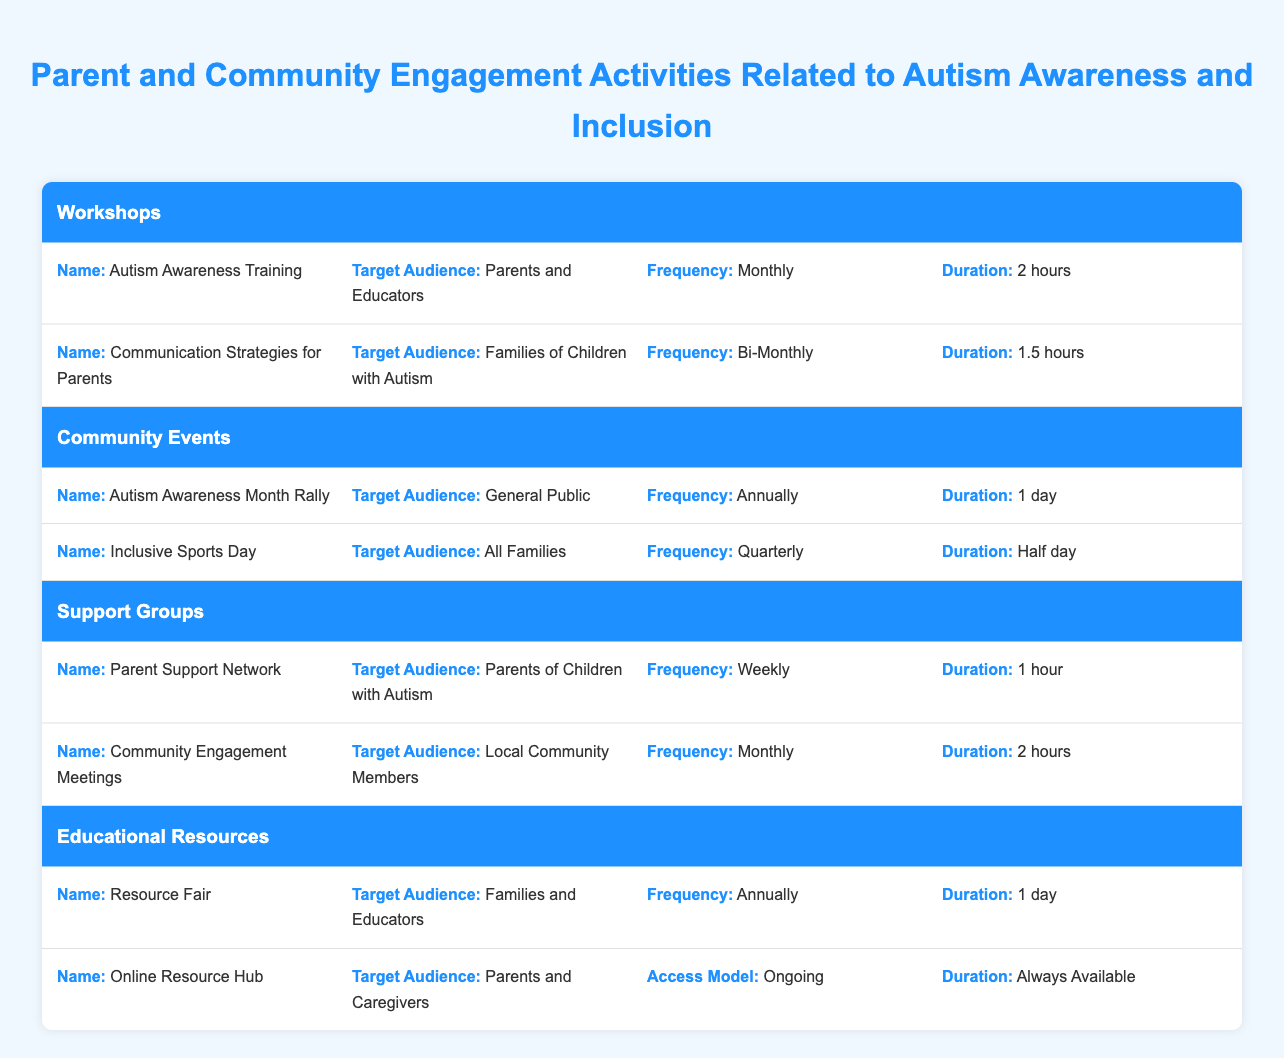What is the duration of the Autism Awareness Training workshop? The table specifies that the Autism Awareness Training workshop has a duration listed as 2 hours.
Answer: 2 hours How frequently does the Parent Support Network meet? According to the table, the Parent Support Network meets weekly.
Answer: Weekly Which community event occurs quarterly? The table indicates that the Inclusive Sports Day is the community event that happens quarterly.
Answer: Inclusive Sports Day Are Communication Strategies for Parents targeted at educators? The table specifies that the target audience for Communication Strategies for Parents is families of children with autism, not educators. Therefore, the statement is false.
Answer: No What is the average duration of the workshops listed? There are two workshops: Autism Awareness Training (2 hours) and Communication Strategies for Parents (1.5 hours). We convert the durations to hours: (2 + 1.5) / 2 = 1.75 hours.
Answer: 1.75 hours How many types of community engagement activities are detailed in the table? The table lists two types of community engagement activities: Autism Awareness Month Rally and Inclusive Sports Day, resulting in a total of 2 types.
Answer: 2 Which activity has the longest duration? By analyzing the durations listed in the workshops, community events, support groups, and educational resources, Autism Awareness Month Rally and Resource Fair both last 1 day (24 hours), which is the longest duration.
Answer: Autism Awareness Month Rally and Resource Fair Is there an ongoing access model for any educational resources? Yes, the Online Resource Hub has an access model described as ongoing, which means it is always available to users. Thus, the answer is true.
Answer: Yes How many hours do support group meetings total per month? The Parent Support Network meets weekly for 1 hour, totaling 4 hours per month (assuming 4 weeks in a month). The Community Engagement Meetings meet monthly for 2 hours. Adding these gives 4 + 2 = 6 hours per month.
Answer: 6 hours 